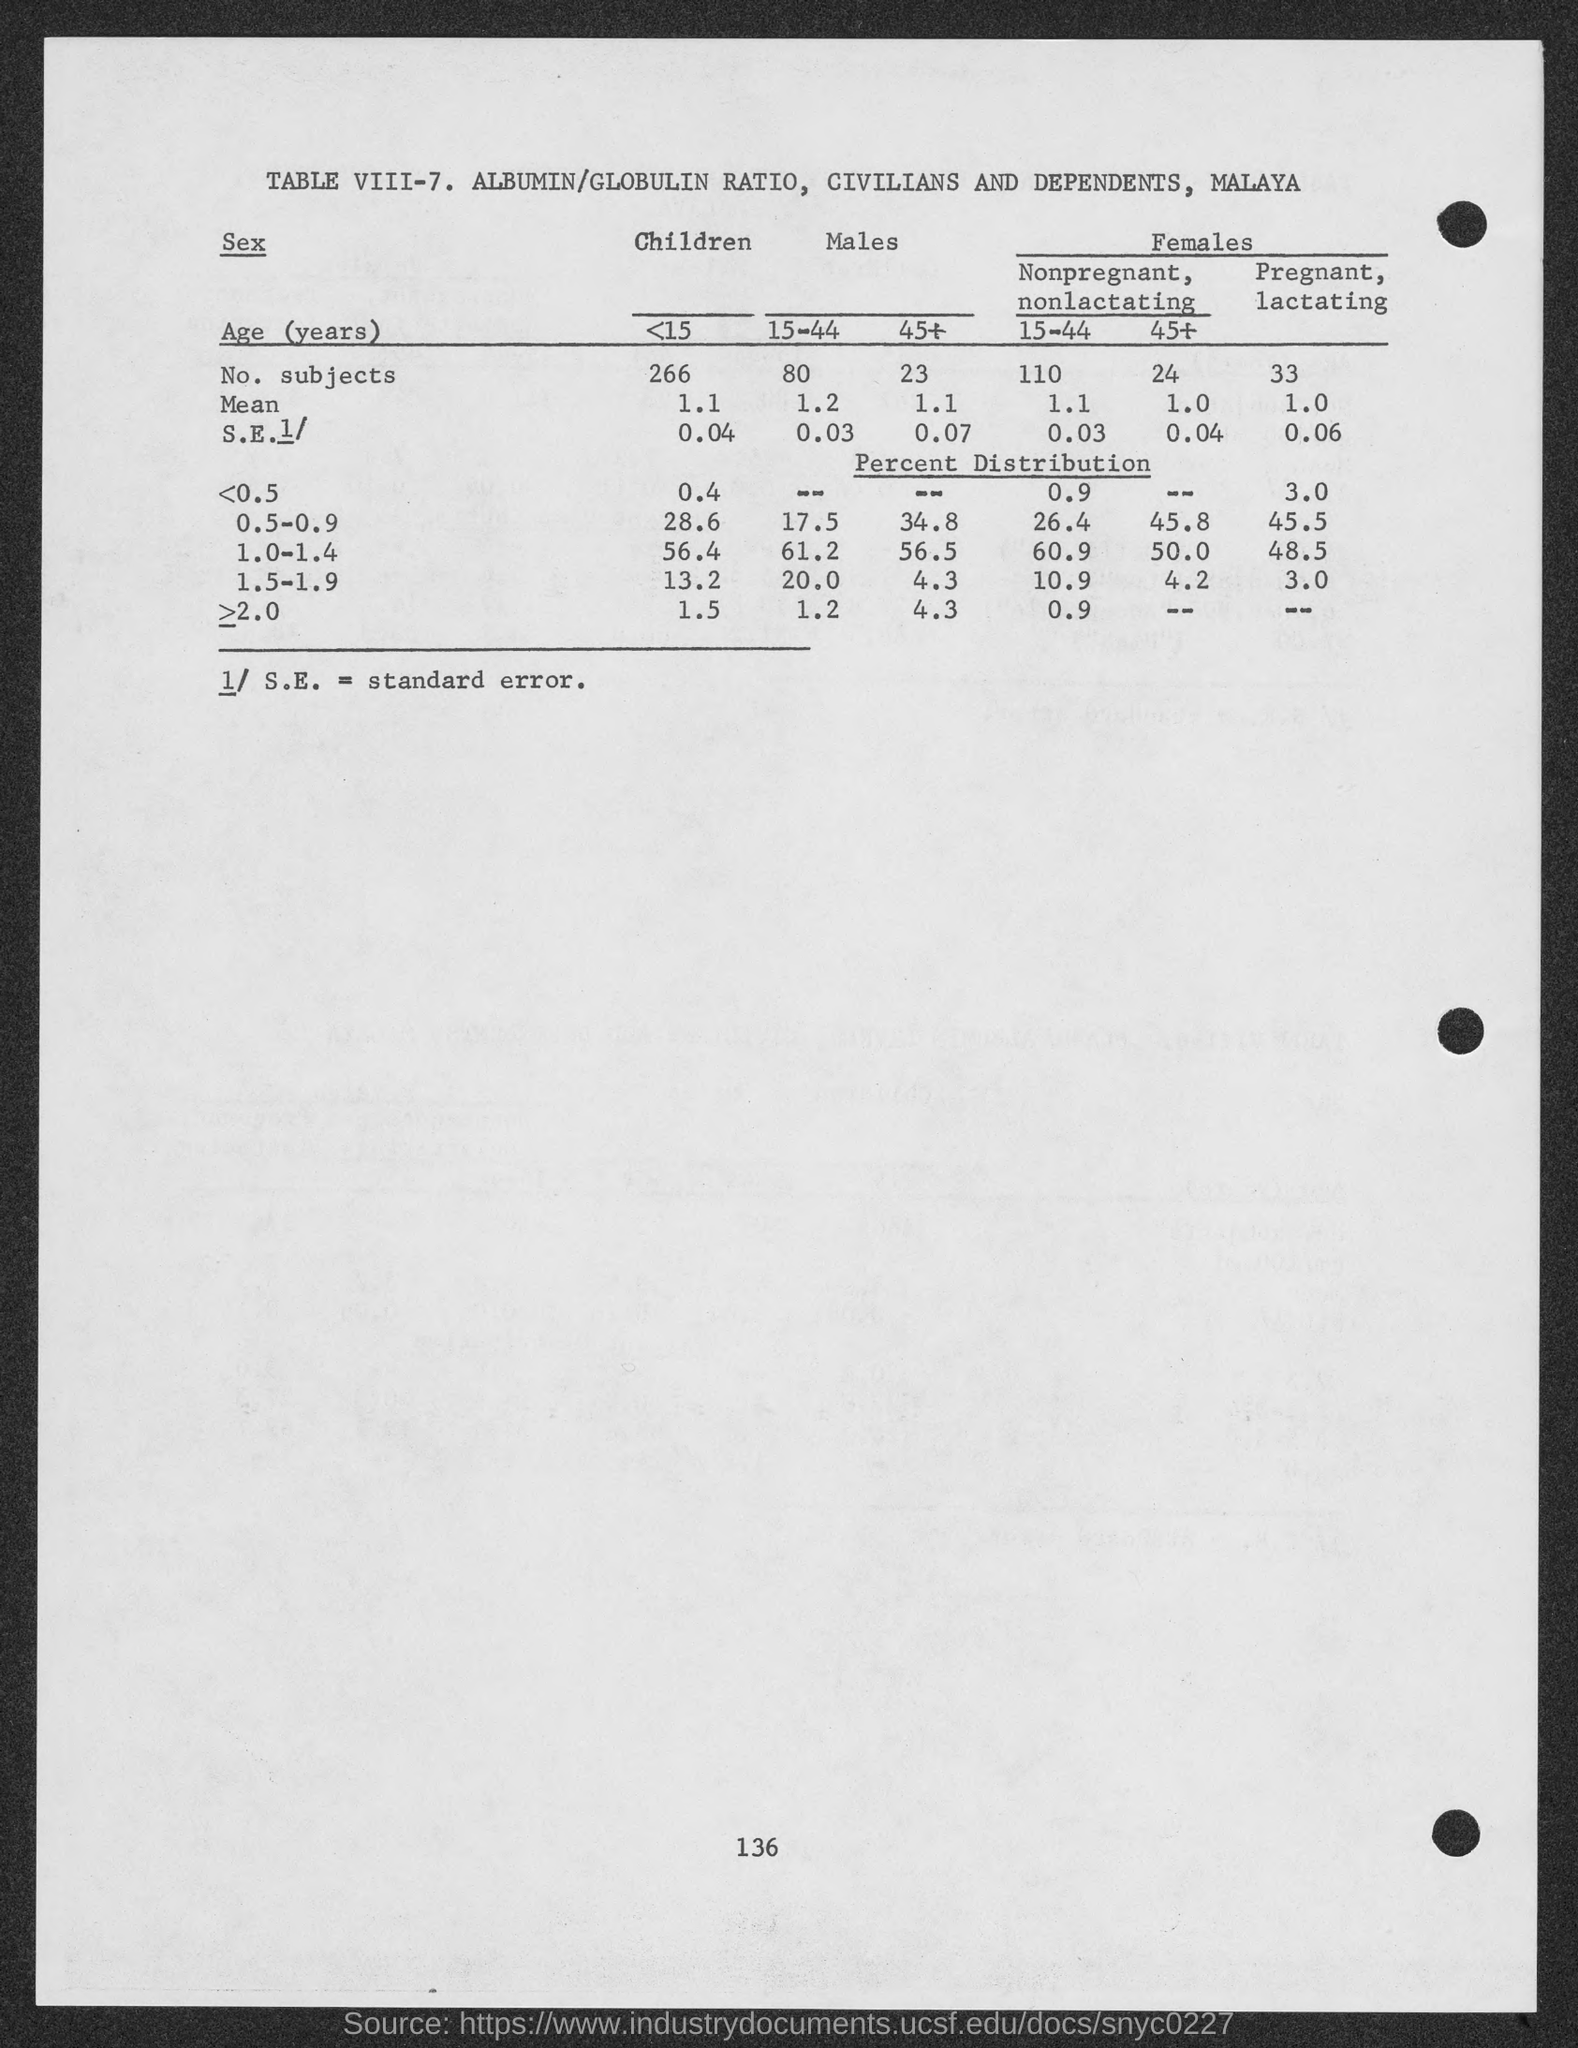Specify some key components in this picture. The mean value of children below 15 years old is 1.1. The age group with the highest number of subjects is <15.. Standard error is a statistical measure that represents the amount of variation in a set of data that is due to the sampling process rather than the true population value. The standard error of the age group 15-44 for males is estimated to be 0.03. 